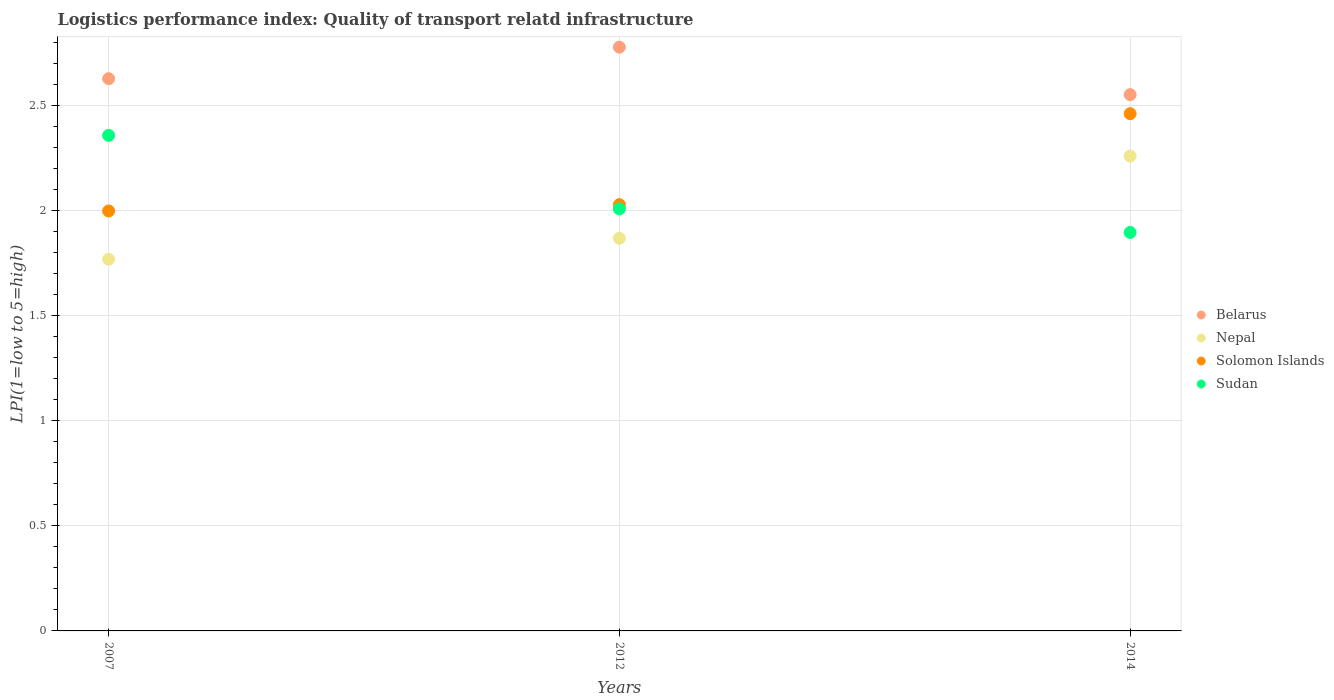What is the logistics performance index in Solomon Islands in 2012?
Keep it short and to the point. 2.03. Across all years, what is the maximum logistics performance index in Sudan?
Offer a terse response. 2.36. Across all years, what is the minimum logistics performance index in Belarus?
Provide a succinct answer. 2.55. In which year was the logistics performance index in Solomon Islands minimum?
Your answer should be very brief. 2007. What is the total logistics performance index in Sudan in the graph?
Your answer should be compact. 6.27. What is the difference between the logistics performance index in Sudan in 2012 and that in 2014?
Offer a terse response. 0.11. What is the difference between the logistics performance index in Belarus in 2012 and the logistics performance index in Solomon Islands in 2007?
Offer a very short reply. 0.78. What is the average logistics performance index in Nepal per year?
Give a very brief answer. 1.97. In the year 2012, what is the difference between the logistics performance index in Nepal and logistics performance index in Belarus?
Your response must be concise. -0.91. In how many years, is the logistics performance index in Nepal greater than 1?
Make the answer very short. 3. What is the ratio of the logistics performance index in Nepal in 2012 to that in 2014?
Make the answer very short. 0.83. Is the difference between the logistics performance index in Nepal in 2007 and 2012 greater than the difference between the logistics performance index in Belarus in 2007 and 2012?
Make the answer very short. Yes. What is the difference between the highest and the second highest logistics performance index in Belarus?
Give a very brief answer. 0.15. What is the difference between the highest and the lowest logistics performance index in Solomon Islands?
Provide a succinct answer. 0.46. Is it the case that in every year, the sum of the logistics performance index in Belarus and logistics performance index in Nepal  is greater than the logistics performance index in Solomon Islands?
Give a very brief answer. Yes. Does the logistics performance index in Nepal monotonically increase over the years?
Offer a terse response. Yes. Is the logistics performance index in Belarus strictly less than the logistics performance index in Sudan over the years?
Offer a very short reply. No. How many dotlines are there?
Provide a short and direct response. 4. What is the difference between two consecutive major ticks on the Y-axis?
Give a very brief answer. 0.5. Are the values on the major ticks of Y-axis written in scientific E-notation?
Your answer should be very brief. No. Does the graph contain grids?
Make the answer very short. Yes. How are the legend labels stacked?
Ensure brevity in your answer.  Vertical. What is the title of the graph?
Your answer should be very brief. Logistics performance index: Quality of transport relatd infrastructure. What is the label or title of the X-axis?
Ensure brevity in your answer.  Years. What is the label or title of the Y-axis?
Ensure brevity in your answer.  LPI(1=low to 5=high). What is the LPI(1=low to 5=high) of Belarus in 2007?
Give a very brief answer. 2.63. What is the LPI(1=low to 5=high) in Nepal in 2007?
Provide a succinct answer. 1.77. What is the LPI(1=low to 5=high) of Sudan in 2007?
Ensure brevity in your answer.  2.36. What is the LPI(1=low to 5=high) in Belarus in 2012?
Your answer should be compact. 2.78. What is the LPI(1=low to 5=high) of Nepal in 2012?
Keep it short and to the point. 1.87. What is the LPI(1=low to 5=high) in Solomon Islands in 2012?
Provide a short and direct response. 2.03. What is the LPI(1=low to 5=high) of Sudan in 2012?
Your answer should be compact. 2.01. What is the LPI(1=low to 5=high) of Belarus in 2014?
Your answer should be compact. 2.55. What is the LPI(1=low to 5=high) in Nepal in 2014?
Your answer should be compact. 2.26. What is the LPI(1=low to 5=high) of Solomon Islands in 2014?
Ensure brevity in your answer.  2.46. What is the LPI(1=low to 5=high) in Sudan in 2014?
Offer a terse response. 1.9. Across all years, what is the maximum LPI(1=low to 5=high) in Belarus?
Your answer should be very brief. 2.78. Across all years, what is the maximum LPI(1=low to 5=high) in Nepal?
Your answer should be very brief. 2.26. Across all years, what is the maximum LPI(1=low to 5=high) in Solomon Islands?
Give a very brief answer. 2.46. Across all years, what is the maximum LPI(1=low to 5=high) in Sudan?
Your answer should be very brief. 2.36. Across all years, what is the minimum LPI(1=low to 5=high) of Belarus?
Provide a succinct answer. 2.55. Across all years, what is the minimum LPI(1=low to 5=high) in Nepal?
Keep it short and to the point. 1.77. Across all years, what is the minimum LPI(1=low to 5=high) of Solomon Islands?
Make the answer very short. 2. Across all years, what is the minimum LPI(1=low to 5=high) of Sudan?
Your response must be concise. 1.9. What is the total LPI(1=low to 5=high) in Belarus in the graph?
Your answer should be very brief. 7.96. What is the total LPI(1=low to 5=high) in Nepal in the graph?
Ensure brevity in your answer.  5.9. What is the total LPI(1=low to 5=high) in Solomon Islands in the graph?
Keep it short and to the point. 6.49. What is the total LPI(1=low to 5=high) in Sudan in the graph?
Make the answer very short. 6.27. What is the difference between the LPI(1=low to 5=high) in Nepal in 2007 and that in 2012?
Offer a very short reply. -0.1. What is the difference between the LPI(1=low to 5=high) in Solomon Islands in 2007 and that in 2012?
Keep it short and to the point. -0.03. What is the difference between the LPI(1=low to 5=high) of Belarus in 2007 and that in 2014?
Provide a succinct answer. 0.08. What is the difference between the LPI(1=low to 5=high) in Nepal in 2007 and that in 2014?
Offer a terse response. -0.49. What is the difference between the LPI(1=low to 5=high) of Solomon Islands in 2007 and that in 2014?
Keep it short and to the point. -0.46. What is the difference between the LPI(1=low to 5=high) of Sudan in 2007 and that in 2014?
Provide a succinct answer. 0.46. What is the difference between the LPI(1=low to 5=high) of Belarus in 2012 and that in 2014?
Offer a terse response. 0.23. What is the difference between the LPI(1=low to 5=high) in Nepal in 2012 and that in 2014?
Your answer should be very brief. -0.39. What is the difference between the LPI(1=low to 5=high) of Solomon Islands in 2012 and that in 2014?
Provide a succinct answer. -0.43. What is the difference between the LPI(1=low to 5=high) in Sudan in 2012 and that in 2014?
Provide a succinct answer. 0.11. What is the difference between the LPI(1=low to 5=high) in Belarus in 2007 and the LPI(1=low to 5=high) in Nepal in 2012?
Provide a short and direct response. 0.76. What is the difference between the LPI(1=low to 5=high) in Belarus in 2007 and the LPI(1=low to 5=high) in Solomon Islands in 2012?
Your answer should be compact. 0.6. What is the difference between the LPI(1=low to 5=high) of Belarus in 2007 and the LPI(1=low to 5=high) of Sudan in 2012?
Your answer should be compact. 0.62. What is the difference between the LPI(1=low to 5=high) in Nepal in 2007 and the LPI(1=low to 5=high) in Solomon Islands in 2012?
Your response must be concise. -0.26. What is the difference between the LPI(1=low to 5=high) of Nepal in 2007 and the LPI(1=low to 5=high) of Sudan in 2012?
Give a very brief answer. -0.24. What is the difference between the LPI(1=low to 5=high) of Solomon Islands in 2007 and the LPI(1=low to 5=high) of Sudan in 2012?
Provide a succinct answer. -0.01. What is the difference between the LPI(1=low to 5=high) of Belarus in 2007 and the LPI(1=low to 5=high) of Nepal in 2014?
Give a very brief answer. 0.37. What is the difference between the LPI(1=low to 5=high) in Belarus in 2007 and the LPI(1=low to 5=high) in Solomon Islands in 2014?
Provide a succinct answer. 0.17. What is the difference between the LPI(1=low to 5=high) in Belarus in 2007 and the LPI(1=low to 5=high) in Sudan in 2014?
Keep it short and to the point. 0.73. What is the difference between the LPI(1=low to 5=high) in Nepal in 2007 and the LPI(1=low to 5=high) in Solomon Islands in 2014?
Provide a succinct answer. -0.69. What is the difference between the LPI(1=low to 5=high) of Nepal in 2007 and the LPI(1=low to 5=high) of Sudan in 2014?
Your response must be concise. -0.13. What is the difference between the LPI(1=low to 5=high) in Solomon Islands in 2007 and the LPI(1=low to 5=high) in Sudan in 2014?
Your response must be concise. 0.1. What is the difference between the LPI(1=low to 5=high) of Belarus in 2012 and the LPI(1=low to 5=high) of Nepal in 2014?
Provide a short and direct response. 0.52. What is the difference between the LPI(1=low to 5=high) in Belarus in 2012 and the LPI(1=low to 5=high) in Solomon Islands in 2014?
Offer a very short reply. 0.32. What is the difference between the LPI(1=low to 5=high) of Belarus in 2012 and the LPI(1=low to 5=high) of Sudan in 2014?
Provide a short and direct response. 0.88. What is the difference between the LPI(1=low to 5=high) of Nepal in 2012 and the LPI(1=low to 5=high) of Solomon Islands in 2014?
Offer a terse response. -0.59. What is the difference between the LPI(1=low to 5=high) of Nepal in 2012 and the LPI(1=low to 5=high) of Sudan in 2014?
Give a very brief answer. -0.03. What is the difference between the LPI(1=low to 5=high) of Solomon Islands in 2012 and the LPI(1=low to 5=high) of Sudan in 2014?
Provide a short and direct response. 0.13. What is the average LPI(1=low to 5=high) of Belarus per year?
Offer a terse response. 2.65. What is the average LPI(1=low to 5=high) in Nepal per year?
Offer a terse response. 1.97. What is the average LPI(1=low to 5=high) in Solomon Islands per year?
Your answer should be compact. 2.16. What is the average LPI(1=low to 5=high) of Sudan per year?
Your answer should be very brief. 2.09. In the year 2007, what is the difference between the LPI(1=low to 5=high) in Belarus and LPI(1=low to 5=high) in Nepal?
Give a very brief answer. 0.86. In the year 2007, what is the difference between the LPI(1=low to 5=high) of Belarus and LPI(1=low to 5=high) of Solomon Islands?
Keep it short and to the point. 0.63. In the year 2007, what is the difference between the LPI(1=low to 5=high) of Belarus and LPI(1=low to 5=high) of Sudan?
Offer a terse response. 0.27. In the year 2007, what is the difference between the LPI(1=low to 5=high) in Nepal and LPI(1=low to 5=high) in Solomon Islands?
Offer a terse response. -0.23. In the year 2007, what is the difference between the LPI(1=low to 5=high) of Nepal and LPI(1=low to 5=high) of Sudan?
Provide a short and direct response. -0.59. In the year 2007, what is the difference between the LPI(1=low to 5=high) of Solomon Islands and LPI(1=low to 5=high) of Sudan?
Provide a short and direct response. -0.36. In the year 2012, what is the difference between the LPI(1=low to 5=high) of Belarus and LPI(1=low to 5=high) of Nepal?
Give a very brief answer. 0.91. In the year 2012, what is the difference between the LPI(1=low to 5=high) in Belarus and LPI(1=low to 5=high) in Solomon Islands?
Your answer should be very brief. 0.75. In the year 2012, what is the difference between the LPI(1=low to 5=high) of Belarus and LPI(1=low to 5=high) of Sudan?
Your answer should be very brief. 0.77. In the year 2012, what is the difference between the LPI(1=low to 5=high) of Nepal and LPI(1=low to 5=high) of Solomon Islands?
Offer a very short reply. -0.16. In the year 2012, what is the difference between the LPI(1=low to 5=high) of Nepal and LPI(1=low to 5=high) of Sudan?
Your answer should be compact. -0.14. In the year 2014, what is the difference between the LPI(1=low to 5=high) of Belarus and LPI(1=low to 5=high) of Nepal?
Offer a very short reply. 0.29. In the year 2014, what is the difference between the LPI(1=low to 5=high) of Belarus and LPI(1=low to 5=high) of Solomon Islands?
Offer a very short reply. 0.09. In the year 2014, what is the difference between the LPI(1=low to 5=high) of Belarus and LPI(1=low to 5=high) of Sudan?
Ensure brevity in your answer.  0.66. In the year 2014, what is the difference between the LPI(1=low to 5=high) in Nepal and LPI(1=low to 5=high) in Solomon Islands?
Provide a short and direct response. -0.2. In the year 2014, what is the difference between the LPI(1=low to 5=high) in Nepal and LPI(1=low to 5=high) in Sudan?
Offer a very short reply. 0.36. In the year 2014, what is the difference between the LPI(1=low to 5=high) of Solomon Islands and LPI(1=low to 5=high) of Sudan?
Make the answer very short. 0.57. What is the ratio of the LPI(1=low to 5=high) in Belarus in 2007 to that in 2012?
Offer a terse response. 0.95. What is the ratio of the LPI(1=low to 5=high) in Nepal in 2007 to that in 2012?
Your answer should be compact. 0.95. What is the ratio of the LPI(1=low to 5=high) of Solomon Islands in 2007 to that in 2012?
Offer a very short reply. 0.99. What is the ratio of the LPI(1=low to 5=high) in Sudan in 2007 to that in 2012?
Offer a very short reply. 1.17. What is the ratio of the LPI(1=low to 5=high) in Belarus in 2007 to that in 2014?
Give a very brief answer. 1.03. What is the ratio of the LPI(1=low to 5=high) in Nepal in 2007 to that in 2014?
Keep it short and to the point. 0.78. What is the ratio of the LPI(1=low to 5=high) of Solomon Islands in 2007 to that in 2014?
Your response must be concise. 0.81. What is the ratio of the LPI(1=low to 5=high) in Sudan in 2007 to that in 2014?
Give a very brief answer. 1.24. What is the ratio of the LPI(1=low to 5=high) of Belarus in 2012 to that in 2014?
Make the answer very short. 1.09. What is the ratio of the LPI(1=low to 5=high) of Nepal in 2012 to that in 2014?
Give a very brief answer. 0.83. What is the ratio of the LPI(1=low to 5=high) of Solomon Islands in 2012 to that in 2014?
Your answer should be very brief. 0.82. What is the ratio of the LPI(1=low to 5=high) in Sudan in 2012 to that in 2014?
Your response must be concise. 1.06. What is the difference between the highest and the second highest LPI(1=low to 5=high) in Belarus?
Your answer should be compact. 0.15. What is the difference between the highest and the second highest LPI(1=low to 5=high) in Nepal?
Your answer should be very brief. 0.39. What is the difference between the highest and the second highest LPI(1=low to 5=high) in Solomon Islands?
Your response must be concise. 0.43. What is the difference between the highest and the lowest LPI(1=low to 5=high) in Belarus?
Your response must be concise. 0.23. What is the difference between the highest and the lowest LPI(1=low to 5=high) in Nepal?
Give a very brief answer. 0.49. What is the difference between the highest and the lowest LPI(1=low to 5=high) of Solomon Islands?
Keep it short and to the point. 0.46. What is the difference between the highest and the lowest LPI(1=low to 5=high) in Sudan?
Provide a succinct answer. 0.46. 